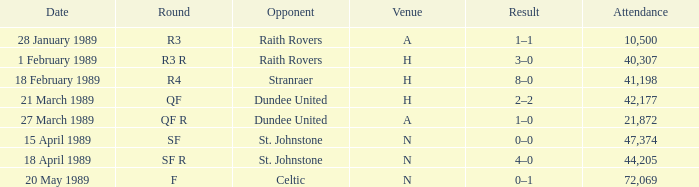What is the date when the round is sf? 15 April 1989. 